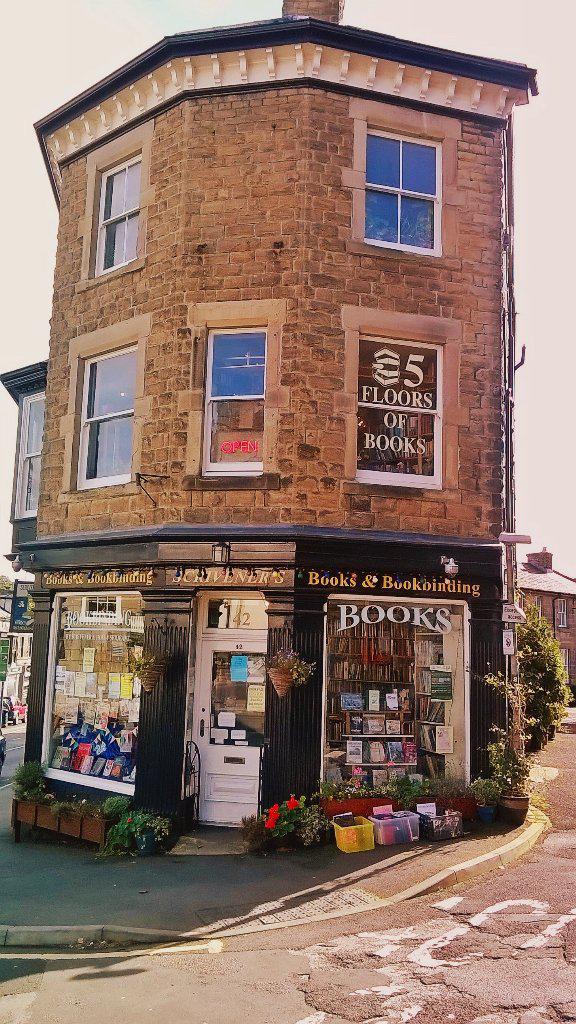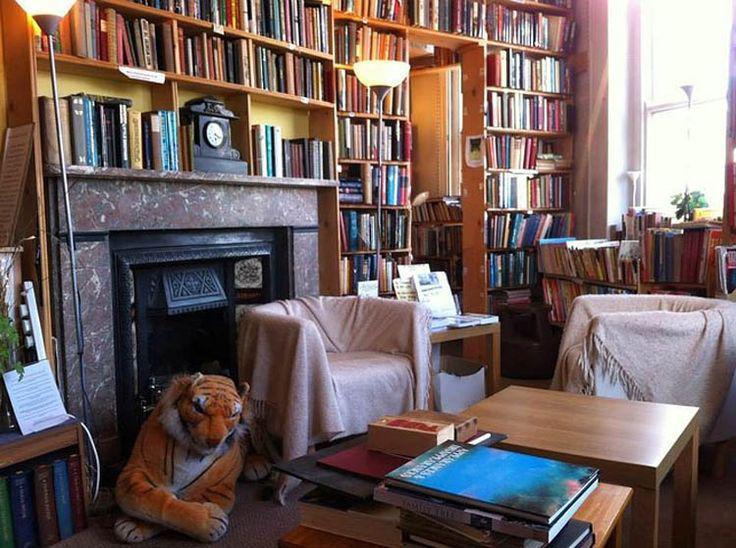The first image is the image on the left, the second image is the image on the right. For the images displayed, is the sentence "To the left of the build there is at least one folding sign advertising the shop." factually correct? Answer yes or no. No. The first image is the image on the left, the second image is the image on the right. Given the left and right images, does the statement "Both images feature the exterior of a bookshop." hold true? Answer yes or no. No. 